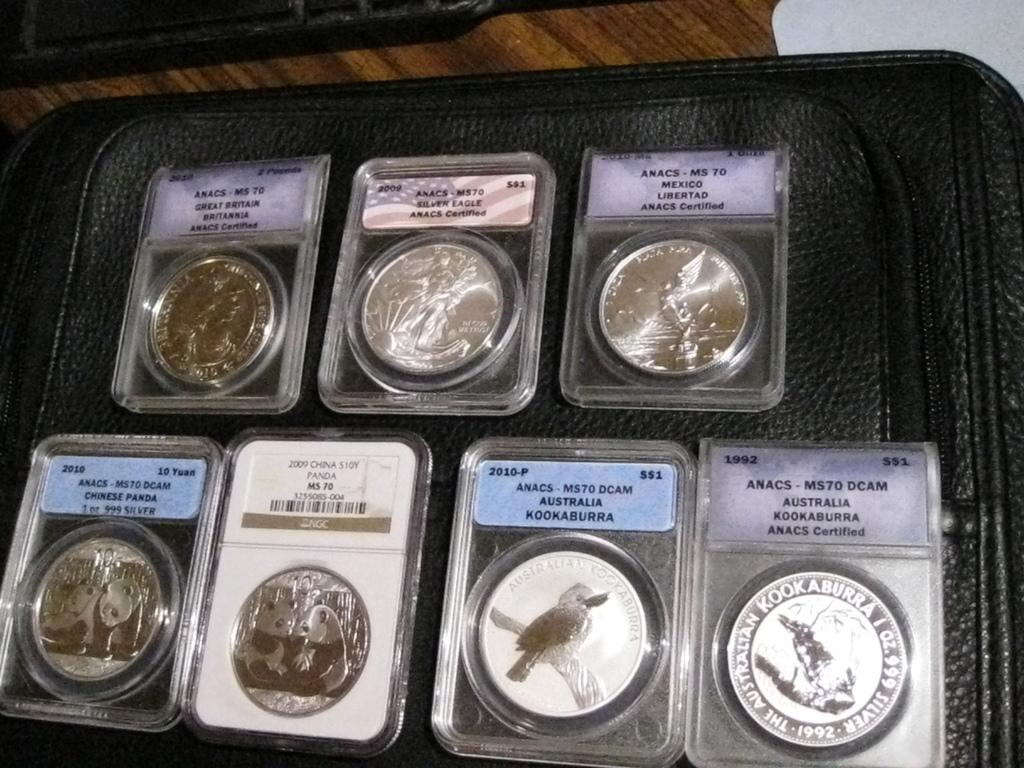<image>
Provide a brief description of the given image. Several coins are in plastic covers and have Australia on the label. 